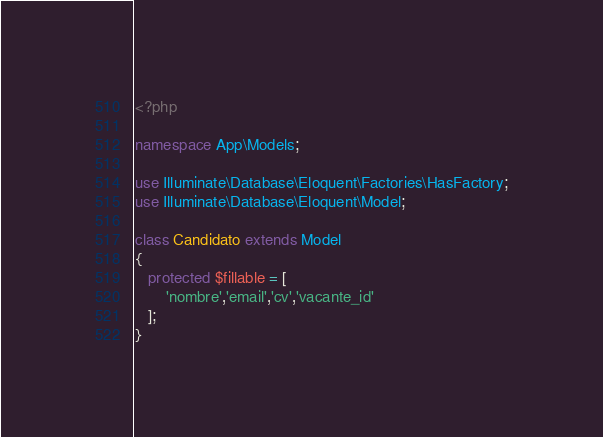Convert code to text. <code><loc_0><loc_0><loc_500><loc_500><_PHP_><?php

namespace App\Models;

use Illuminate\Database\Eloquent\Factories\HasFactory;
use Illuminate\Database\Eloquent\Model;

class Candidato extends Model
{
   protected $fillable = [
       'nombre','email','cv','vacante_id'
   ];
}
</code> 